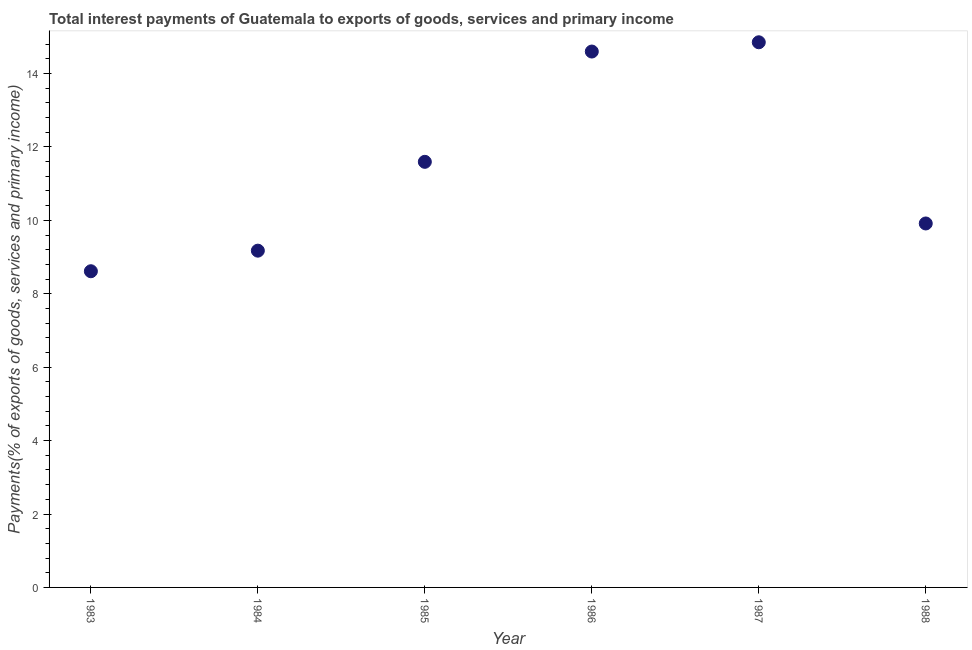What is the total interest payments on external debt in 1985?
Provide a succinct answer. 11.59. Across all years, what is the maximum total interest payments on external debt?
Your answer should be compact. 14.85. Across all years, what is the minimum total interest payments on external debt?
Your answer should be compact. 8.61. In which year was the total interest payments on external debt maximum?
Offer a terse response. 1987. What is the sum of the total interest payments on external debt?
Your response must be concise. 68.74. What is the difference between the total interest payments on external debt in 1984 and 1988?
Offer a terse response. -0.74. What is the average total interest payments on external debt per year?
Your response must be concise. 11.46. What is the median total interest payments on external debt?
Your response must be concise. 10.75. Do a majority of the years between 1983 and 1984 (inclusive) have total interest payments on external debt greater than 3.2 %?
Offer a terse response. Yes. What is the ratio of the total interest payments on external debt in 1983 to that in 1985?
Your answer should be compact. 0.74. What is the difference between the highest and the second highest total interest payments on external debt?
Provide a succinct answer. 0.25. Is the sum of the total interest payments on external debt in 1984 and 1987 greater than the maximum total interest payments on external debt across all years?
Keep it short and to the point. Yes. What is the difference between the highest and the lowest total interest payments on external debt?
Offer a very short reply. 6.24. In how many years, is the total interest payments on external debt greater than the average total interest payments on external debt taken over all years?
Make the answer very short. 3. Are the values on the major ticks of Y-axis written in scientific E-notation?
Give a very brief answer. No. Does the graph contain grids?
Ensure brevity in your answer.  No. What is the title of the graph?
Provide a short and direct response. Total interest payments of Guatemala to exports of goods, services and primary income. What is the label or title of the Y-axis?
Your answer should be very brief. Payments(% of exports of goods, services and primary income). What is the Payments(% of exports of goods, services and primary income) in 1983?
Give a very brief answer. 8.61. What is the Payments(% of exports of goods, services and primary income) in 1984?
Your answer should be very brief. 9.17. What is the Payments(% of exports of goods, services and primary income) in 1985?
Make the answer very short. 11.59. What is the Payments(% of exports of goods, services and primary income) in 1986?
Keep it short and to the point. 14.6. What is the Payments(% of exports of goods, services and primary income) in 1987?
Provide a succinct answer. 14.85. What is the Payments(% of exports of goods, services and primary income) in 1988?
Offer a terse response. 9.91. What is the difference between the Payments(% of exports of goods, services and primary income) in 1983 and 1984?
Offer a terse response. -0.56. What is the difference between the Payments(% of exports of goods, services and primary income) in 1983 and 1985?
Your response must be concise. -2.98. What is the difference between the Payments(% of exports of goods, services and primary income) in 1983 and 1986?
Provide a short and direct response. -5.98. What is the difference between the Payments(% of exports of goods, services and primary income) in 1983 and 1987?
Give a very brief answer. -6.24. What is the difference between the Payments(% of exports of goods, services and primary income) in 1983 and 1988?
Give a very brief answer. -1.3. What is the difference between the Payments(% of exports of goods, services and primary income) in 1984 and 1985?
Keep it short and to the point. -2.42. What is the difference between the Payments(% of exports of goods, services and primary income) in 1984 and 1986?
Your answer should be compact. -5.42. What is the difference between the Payments(% of exports of goods, services and primary income) in 1984 and 1987?
Offer a terse response. -5.68. What is the difference between the Payments(% of exports of goods, services and primary income) in 1984 and 1988?
Offer a very short reply. -0.74. What is the difference between the Payments(% of exports of goods, services and primary income) in 1985 and 1986?
Your answer should be compact. -3. What is the difference between the Payments(% of exports of goods, services and primary income) in 1985 and 1987?
Give a very brief answer. -3.26. What is the difference between the Payments(% of exports of goods, services and primary income) in 1985 and 1988?
Keep it short and to the point. 1.68. What is the difference between the Payments(% of exports of goods, services and primary income) in 1986 and 1987?
Your answer should be very brief. -0.25. What is the difference between the Payments(% of exports of goods, services and primary income) in 1986 and 1988?
Your answer should be very brief. 4.68. What is the difference between the Payments(% of exports of goods, services and primary income) in 1987 and 1988?
Ensure brevity in your answer.  4.94. What is the ratio of the Payments(% of exports of goods, services and primary income) in 1983 to that in 1984?
Your answer should be compact. 0.94. What is the ratio of the Payments(% of exports of goods, services and primary income) in 1983 to that in 1985?
Your response must be concise. 0.74. What is the ratio of the Payments(% of exports of goods, services and primary income) in 1983 to that in 1986?
Your response must be concise. 0.59. What is the ratio of the Payments(% of exports of goods, services and primary income) in 1983 to that in 1987?
Ensure brevity in your answer.  0.58. What is the ratio of the Payments(% of exports of goods, services and primary income) in 1983 to that in 1988?
Ensure brevity in your answer.  0.87. What is the ratio of the Payments(% of exports of goods, services and primary income) in 1984 to that in 1985?
Your answer should be very brief. 0.79. What is the ratio of the Payments(% of exports of goods, services and primary income) in 1984 to that in 1986?
Provide a short and direct response. 0.63. What is the ratio of the Payments(% of exports of goods, services and primary income) in 1984 to that in 1987?
Make the answer very short. 0.62. What is the ratio of the Payments(% of exports of goods, services and primary income) in 1984 to that in 1988?
Offer a very short reply. 0.93. What is the ratio of the Payments(% of exports of goods, services and primary income) in 1985 to that in 1986?
Provide a succinct answer. 0.79. What is the ratio of the Payments(% of exports of goods, services and primary income) in 1985 to that in 1987?
Make the answer very short. 0.78. What is the ratio of the Payments(% of exports of goods, services and primary income) in 1985 to that in 1988?
Offer a terse response. 1.17. What is the ratio of the Payments(% of exports of goods, services and primary income) in 1986 to that in 1988?
Your answer should be compact. 1.47. What is the ratio of the Payments(% of exports of goods, services and primary income) in 1987 to that in 1988?
Your response must be concise. 1.5. 